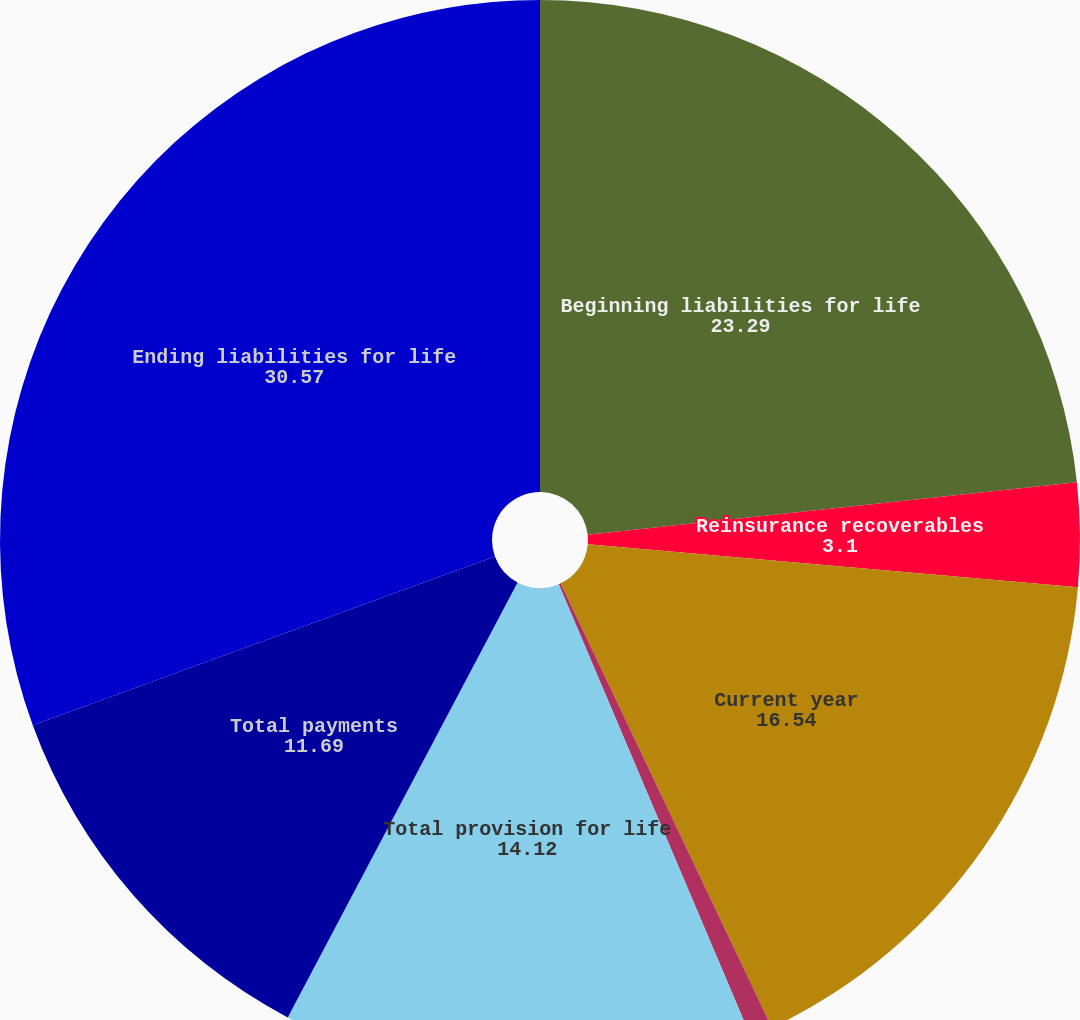Convert chart. <chart><loc_0><loc_0><loc_500><loc_500><pie_chart><fcel>Beginning liabilities for life<fcel>Reinsurance recoverables<fcel>Current year<fcel>Prior years<fcel>Total provision for life<fcel>Total payments<fcel>Ending liabilities for life<nl><fcel>23.29%<fcel>3.1%<fcel>16.54%<fcel>0.68%<fcel>14.12%<fcel>11.69%<fcel>30.57%<nl></chart> 